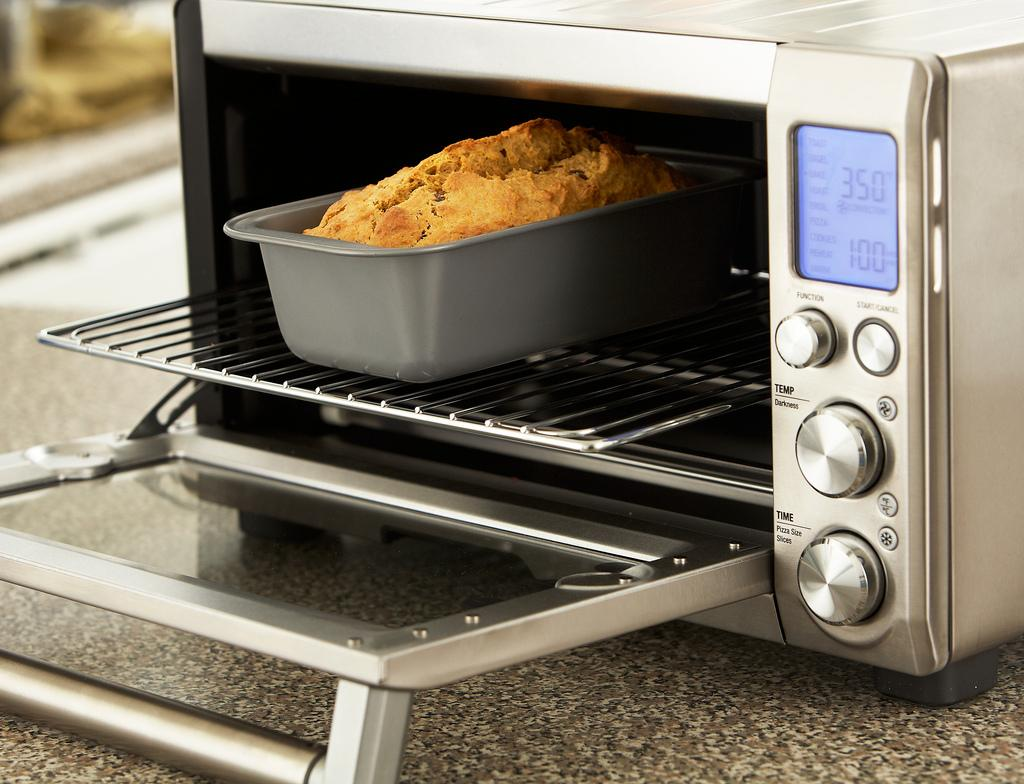Provide a one-sentence caption for the provided image. The bread is sitting in an toaster oven that is set from 350 degrees. 